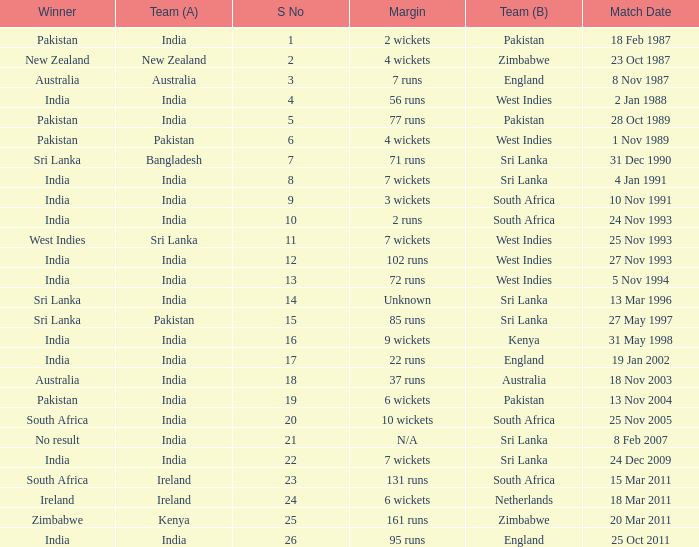How many games were won by a margin of 131 runs? 1.0. 